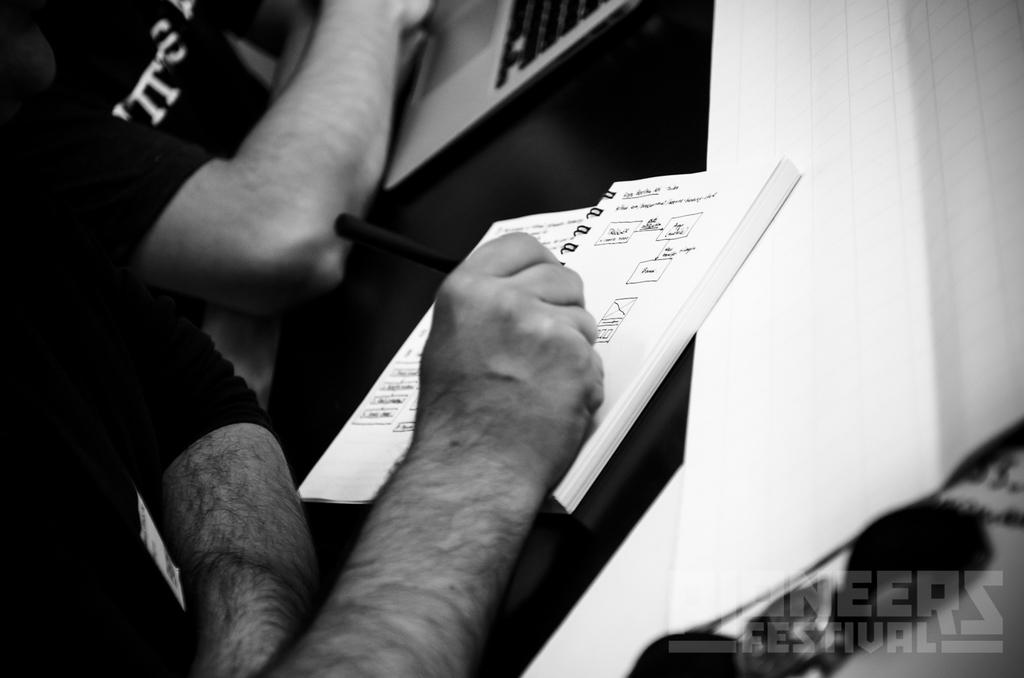How many people are in the image? There are two persons in the image. What is one person holding in the image? One person is holding a pen. What objects can be seen on the table in the image? There is a laptop and a book on the table. Is there any text or marking in the image? Yes, there is a watermark in the bottom right side of the image. What type of meal is being prepared by the person holding the pen in the image? There is no indication of a meal being prepared in the image. The person holding the pen is not engaged in any cooking or food preparation activities. 